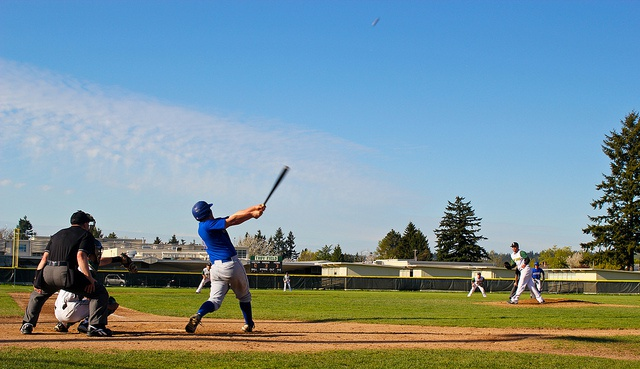Describe the objects in this image and their specific colors. I can see people in gray, black, and maroon tones, people in gray, black, navy, and lightgray tones, people in gray, black, white, and maroon tones, people in gray, white, black, and darkgray tones, and people in gray, white, and black tones in this image. 